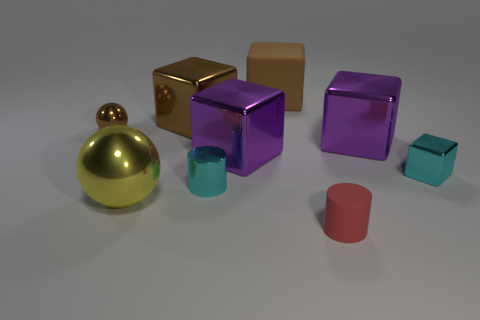Are the cyan object that is behind the shiny cylinder and the tiny cylinder in front of the big yellow object made of the same material? While the photo doesn't provide definitive material properties, the two cyan objects, one behind the shiny gold sphere and the smaller one in front of the larger yellow cube, exhibit similar visual textures and color reflections suggesting they could possibly be made of the same or similar types of materials. 